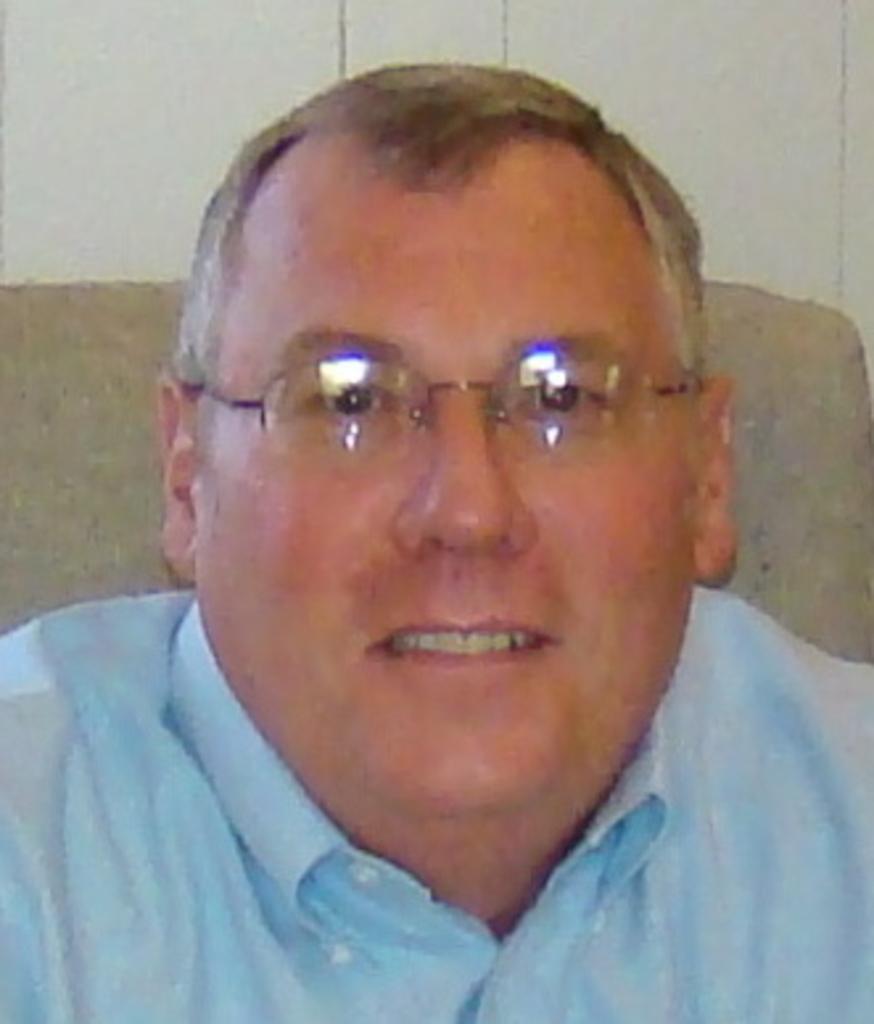In one or two sentences, can you explain what this image depicts? There is a person wearing specs is smiling. In the back there is a wall. 